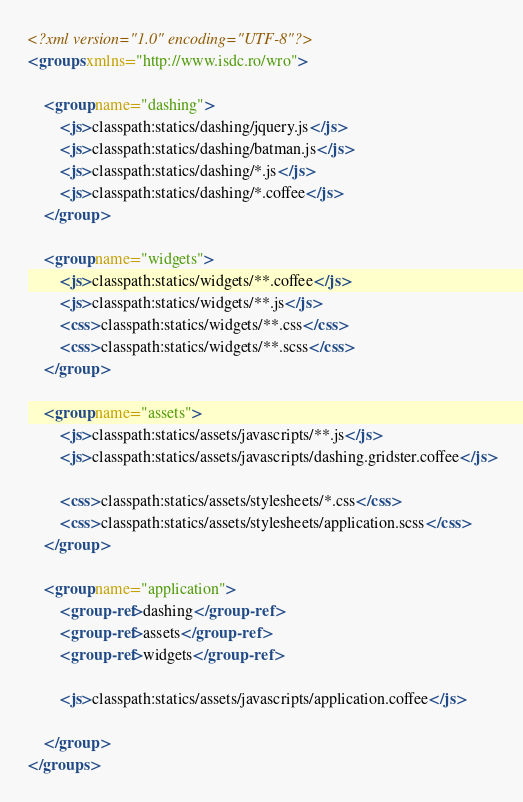<code> <loc_0><loc_0><loc_500><loc_500><_XML_><?xml version="1.0" encoding="UTF-8"?>
<groups xmlns="http://www.isdc.ro/wro">

    <group name="dashing">
        <js>classpath:statics/dashing/jquery.js</js>
        <js>classpath:statics/dashing/batman.js</js>
        <js>classpath:statics/dashing/*.js</js>
        <js>classpath:statics/dashing/*.coffee</js>
    </group>

    <group name="widgets">
        <js>classpath:statics/widgets/**.coffee</js>
        <js>classpath:statics/widgets/**.js</js>
        <css>classpath:statics/widgets/**.css</css>
        <css>classpath:statics/widgets/**.scss</css>
    </group>

    <group name="assets">
        <js>classpath:statics/assets/javascripts/**.js</js>
        <js>classpath:statics/assets/javascripts/dashing.gridster.coffee</js>

        <css>classpath:statics/assets/stylesheets/*.css</css>
        <css>classpath:statics/assets/stylesheets/application.scss</css>
    </group>

    <group name="application">
        <group-ref>dashing</group-ref>
        <group-ref>assets</group-ref>
        <group-ref>widgets</group-ref>

        <js>classpath:statics/assets/javascripts/application.coffee</js>

    </group>
</groups>
</code> 